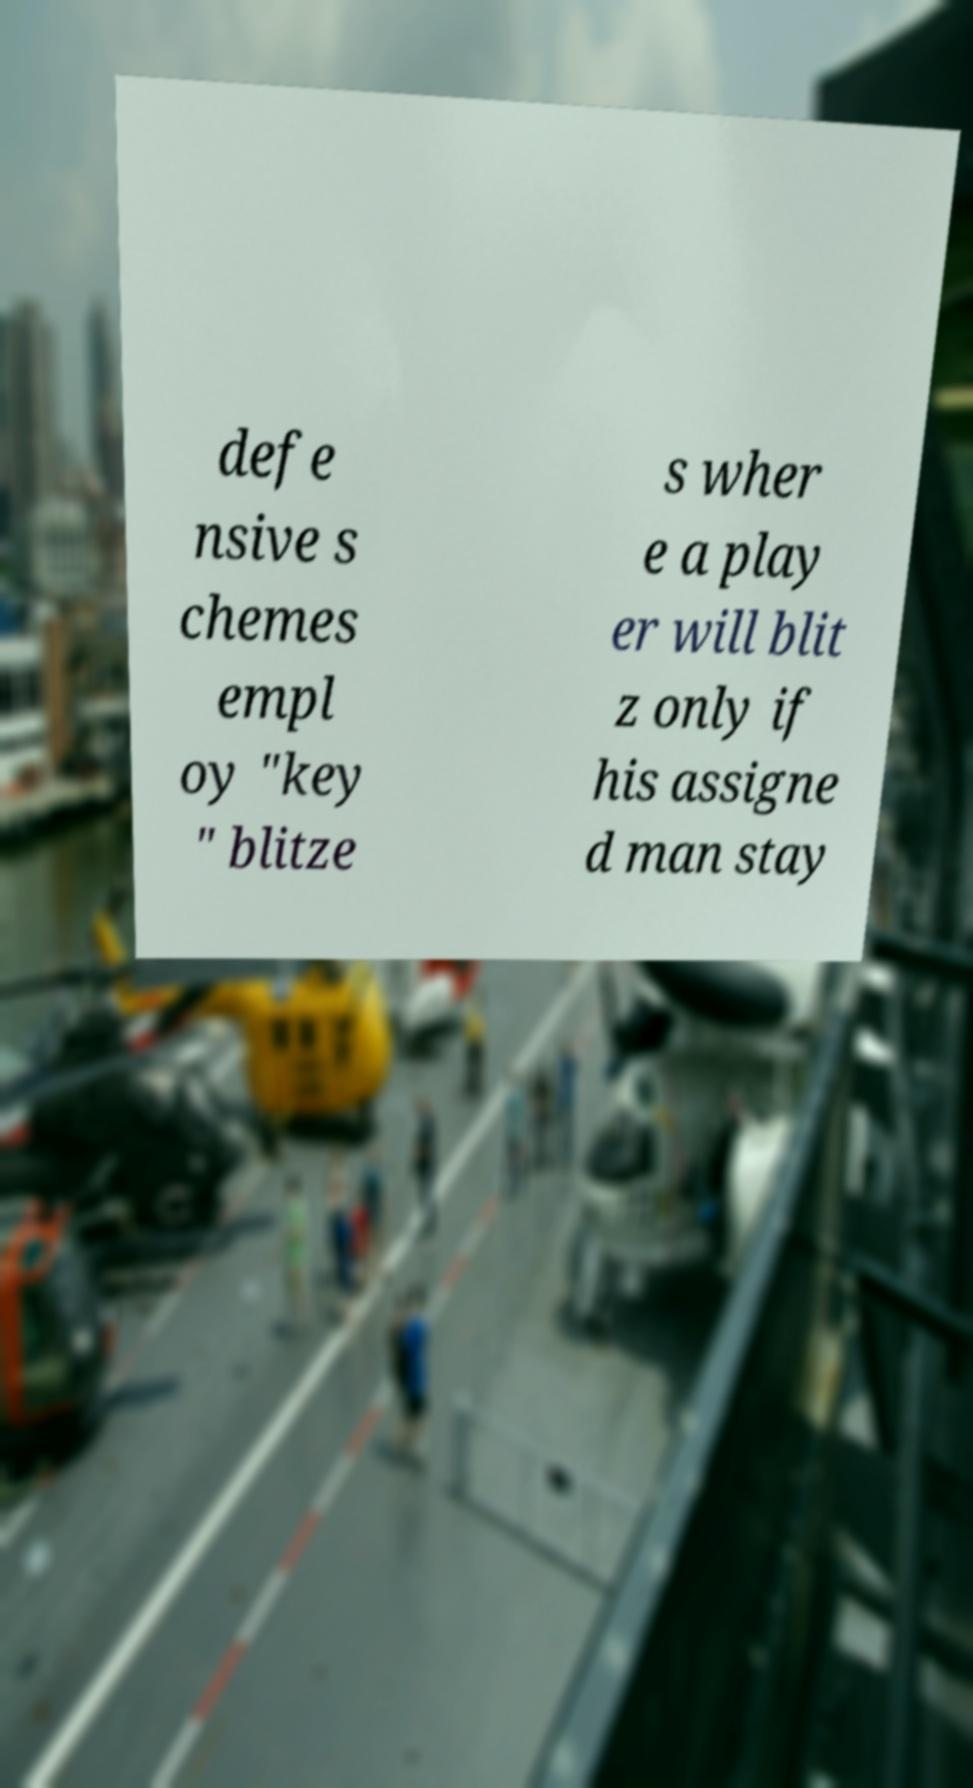What messages or text are displayed in this image? I need them in a readable, typed format. defe nsive s chemes empl oy "key " blitze s wher e a play er will blit z only if his assigne d man stay 